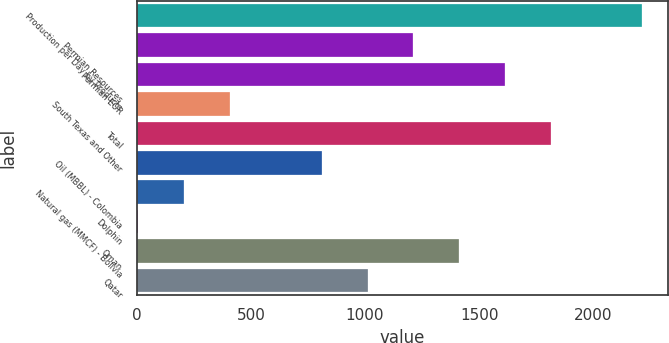Convert chart. <chart><loc_0><loc_0><loc_500><loc_500><bar_chart><fcel>Production per Day by Products<fcel>Permian Resources<fcel>Permian EOR<fcel>South Texas and Other<fcel>Total<fcel>Oil (MBBL) - Colombia<fcel>Natural gas (MMCF) - Bolivia<fcel>Dolphin<fcel>Oman<fcel>Qatar<nl><fcel>2215.8<fcel>1211.8<fcel>1613.4<fcel>408.6<fcel>1814.2<fcel>810.2<fcel>207.8<fcel>7<fcel>1412.6<fcel>1011<nl></chart> 